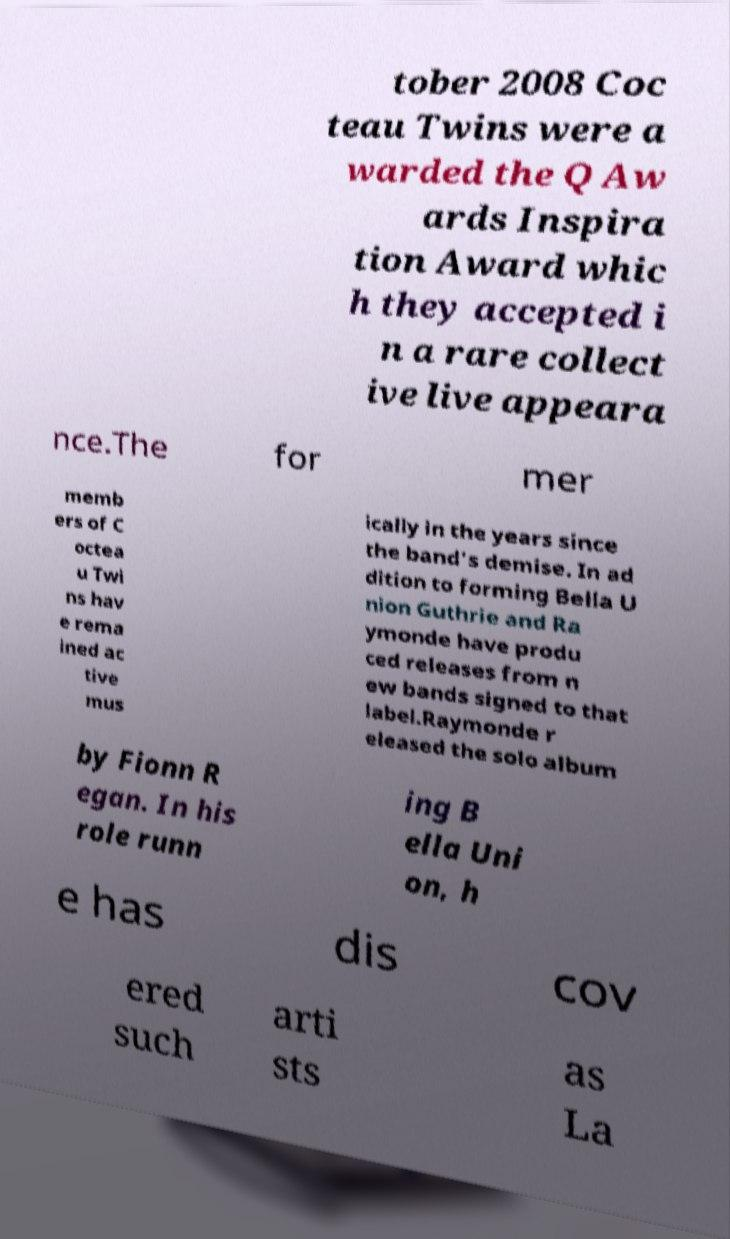There's text embedded in this image that I need extracted. Can you transcribe it verbatim? tober 2008 Coc teau Twins were a warded the Q Aw ards Inspira tion Award whic h they accepted i n a rare collect ive live appeara nce.The for mer memb ers of C octea u Twi ns hav e rema ined ac tive mus ically in the years since the band's demise. In ad dition to forming Bella U nion Guthrie and Ra ymonde have produ ced releases from n ew bands signed to that label.Raymonde r eleased the solo album by Fionn R egan. In his role runn ing B ella Uni on, h e has dis cov ered such arti sts as La 